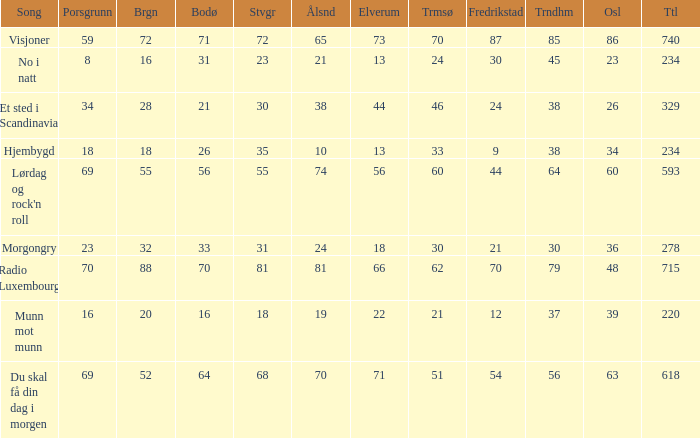When the total score is 740, what is tromso? 70.0. 